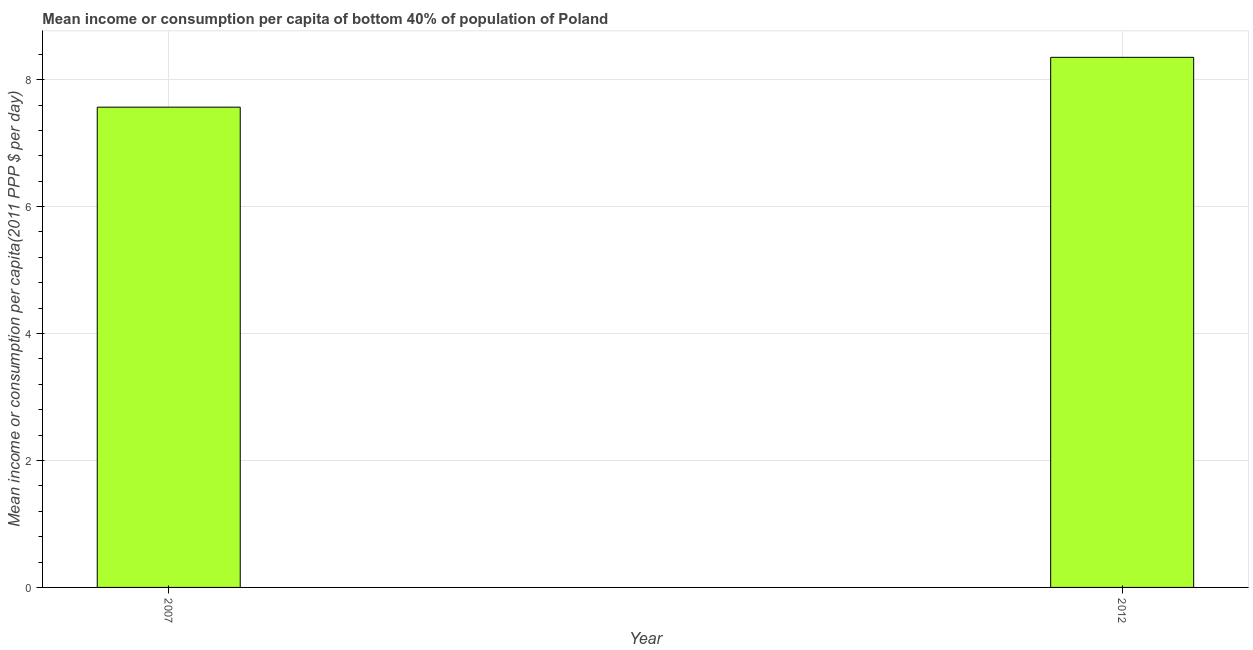Does the graph contain grids?
Give a very brief answer. Yes. What is the title of the graph?
Give a very brief answer. Mean income or consumption per capita of bottom 40% of population of Poland. What is the label or title of the Y-axis?
Give a very brief answer. Mean income or consumption per capita(2011 PPP $ per day). What is the mean income or consumption in 2007?
Your answer should be very brief. 7.57. Across all years, what is the maximum mean income or consumption?
Make the answer very short. 8.35. Across all years, what is the minimum mean income or consumption?
Provide a short and direct response. 7.57. In which year was the mean income or consumption maximum?
Give a very brief answer. 2012. What is the sum of the mean income or consumption?
Give a very brief answer. 15.92. What is the difference between the mean income or consumption in 2007 and 2012?
Your response must be concise. -0.79. What is the average mean income or consumption per year?
Offer a very short reply. 7.96. What is the median mean income or consumption?
Provide a succinct answer. 7.96. In how many years, is the mean income or consumption greater than 5.2 $?
Offer a terse response. 2. Do a majority of the years between 2007 and 2012 (inclusive) have mean income or consumption greater than 1.2 $?
Your answer should be compact. Yes. What is the ratio of the mean income or consumption in 2007 to that in 2012?
Make the answer very short. 0.91. Are all the bars in the graph horizontal?
Make the answer very short. No. What is the difference between two consecutive major ticks on the Y-axis?
Your response must be concise. 2. Are the values on the major ticks of Y-axis written in scientific E-notation?
Give a very brief answer. No. What is the Mean income or consumption per capita(2011 PPP $ per day) of 2007?
Give a very brief answer. 7.57. What is the Mean income or consumption per capita(2011 PPP $ per day) in 2012?
Make the answer very short. 8.35. What is the difference between the Mean income or consumption per capita(2011 PPP $ per day) in 2007 and 2012?
Keep it short and to the point. -0.78. What is the ratio of the Mean income or consumption per capita(2011 PPP $ per day) in 2007 to that in 2012?
Offer a very short reply. 0.91. 